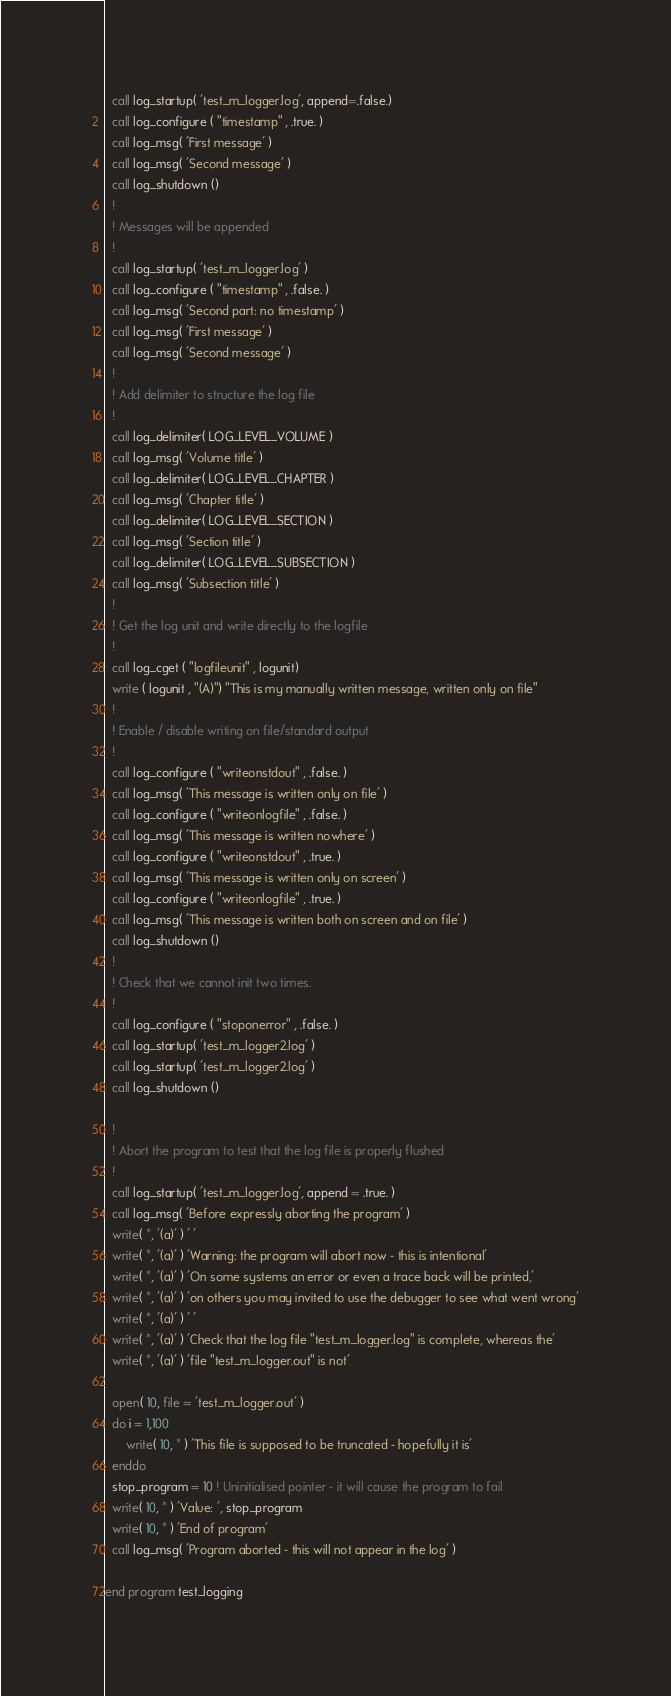<code> <loc_0><loc_0><loc_500><loc_500><_FORTRAN_>  call log_startup( 'test_m_logger.log', append=.false.)
  call log_configure ( "timestamp" , .true. )
  call log_msg( 'First message' )
  call log_msg( 'Second message' )
  call log_shutdown ()
  !
  ! Messages will be appended
  !
  call log_startup( 'test_m_logger.log' )
  call log_configure ( "timestamp" , .false. )
  call log_msg( 'Second part: no timestamp' )
  call log_msg( 'First message' )
  call log_msg( 'Second message' )
  !
  ! Add delimiter to structure the log file
  !
  call log_delimiter( LOG_LEVEL_VOLUME )
  call log_msg( 'Volume title' )
  call log_delimiter( LOG_LEVEL_CHAPTER )
  call log_msg( 'Chapter title' )
  call log_delimiter( LOG_LEVEL_SECTION )
  call log_msg( 'Section title' )
  call log_delimiter( LOG_LEVEL_SUBSECTION )
  call log_msg( 'Subsection title' )
  !
  ! Get the log unit and write directly to the logfile
  !
  call log_cget ( "logfileunit" , logunit)
  write ( logunit , "(A)") "This is my manually written message, written only on file"
  !
  ! Enable / disable writing on file/standard output
  !
  call log_configure ( "writeonstdout" , .false. )
  call log_msg( 'This message is written only on file' )
  call log_configure ( "writeonlogfile" , .false. )
  call log_msg( 'This message is written nowhere' )
  call log_configure ( "writeonstdout" , .true. )
  call log_msg( 'This message is written only on screen' )
  call log_configure ( "writeonlogfile" , .true. )
  call log_msg( 'This message is written both on screen and on file' )
  call log_shutdown ()
  !
  ! Check that we cannot init two times.
  !
  call log_configure ( "stoponerror" , .false. )
  call log_startup( 'test_m_logger2.log' )
  call log_startup( 'test_m_logger2.log' )
  call log_shutdown ()

  !
  ! Abort the program to test that the log file is properly flushed
  !
  call log_startup( 'test_m_logger.log', append = .true. )
  call log_msg( 'Before expressly aborting the program' )
  write( *, '(a)' ) ' '
  write( *, '(a)' ) 'Warning: the program will abort now - this is intentional'
  write( *, '(a)' ) 'On some systems an error or even a trace back will be printed,'
  write( *, '(a)' ) 'on others you may invited to use the debugger to see what went wrong'
  write( *, '(a)' ) ' '
  write( *, '(a)' ) 'Check that the log file "test_m_logger.log" is complete, whereas the'
  write( *, '(a)' ) 'file "test_m_logger.out" is not'

  open( 10, file = 'test_m_logger.out' )
  do i = 1,100
      write( 10, * ) 'This file is supposed to be truncated - hopefully it is'
  enddo
  stop_program = 10 ! Uninitialised pointer - it will cause the program to fail
  write( 10, * ) 'Value: ', stop_program
  write( 10, * ) 'End of program'
  call log_msg( 'Program aborted - this will not appear in the log' )

end program test_logging
</code> 